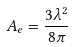Convert formula to latex. <formula><loc_0><loc_0><loc_500><loc_500>A _ { e } = \frac { 3 \lambda ^ { 2 } } { 8 \pi }</formula> 